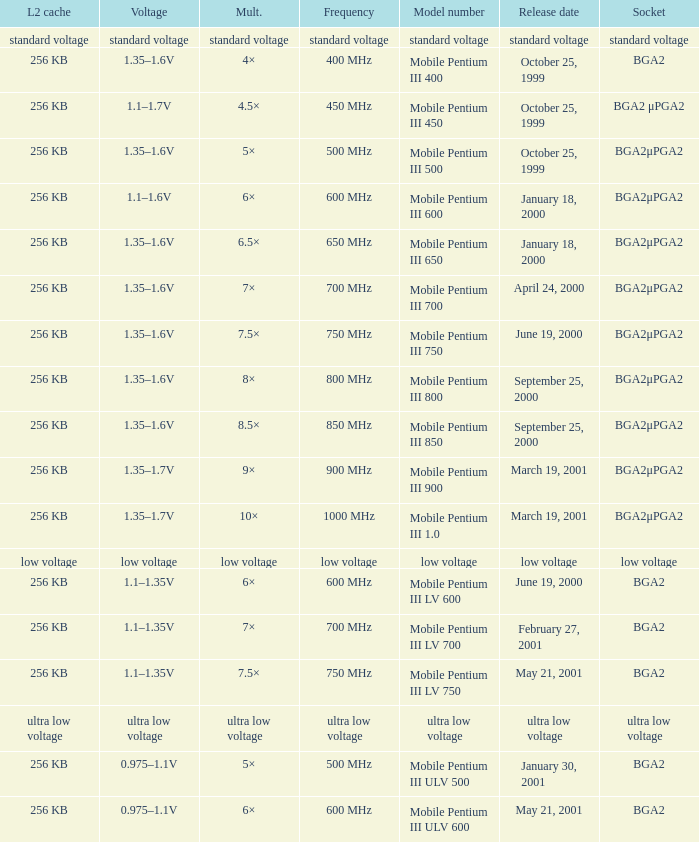What model number uses standard voltage socket? Standard voltage. 